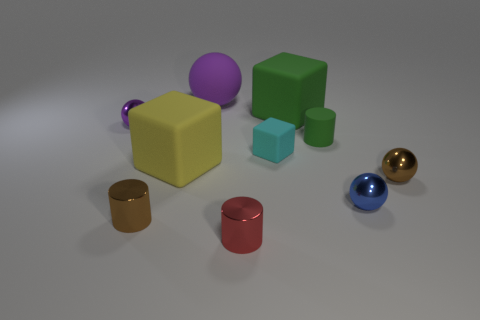Subtract all tiny brown metallic spheres. How many spheres are left? 3 Subtract all brown spheres. How many spheres are left? 3 Subtract all green spheres. Subtract all gray cylinders. How many spheres are left? 4 Subtract all cubes. How many objects are left? 7 Add 8 big green matte blocks. How many big green matte blocks are left? 9 Add 5 purple rubber cylinders. How many purple rubber cylinders exist? 5 Subtract 0 cyan cylinders. How many objects are left? 10 Subtract all tiny blue matte blocks. Subtract all small cyan blocks. How many objects are left? 9 